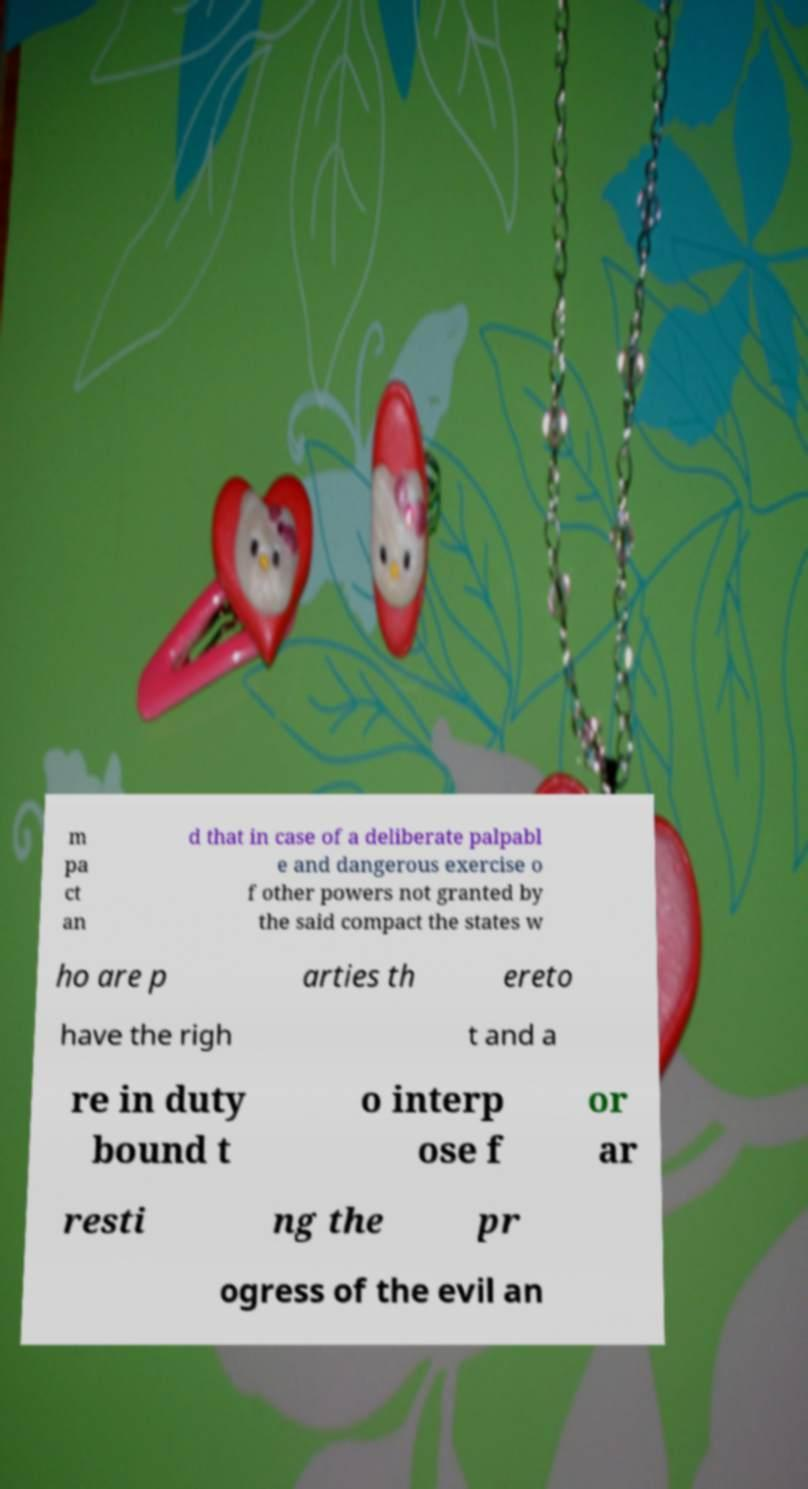Please read and relay the text visible in this image. What does it say? m pa ct an d that in case of a deliberate palpabl e and dangerous exercise o f other powers not granted by the said compact the states w ho are p arties th ereto have the righ t and a re in duty bound t o interp ose f or ar resti ng the pr ogress of the evil an 